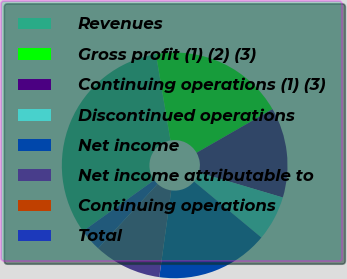Convert chart to OTSL. <chart><loc_0><loc_0><loc_500><loc_500><pie_chart><fcel>Revenues<fcel>Gross profit (1) (2) (3)<fcel>Continuing operations (1) (3)<fcel>Discontinued operations<fcel>Net income<fcel>Net income attributable to<fcel>Continuing operations<fcel>Total<nl><fcel>32.26%<fcel>19.35%<fcel>12.9%<fcel>6.45%<fcel>16.13%<fcel>9.68%<fcel>0.0%<fcel>3.23%<nl></chart> 